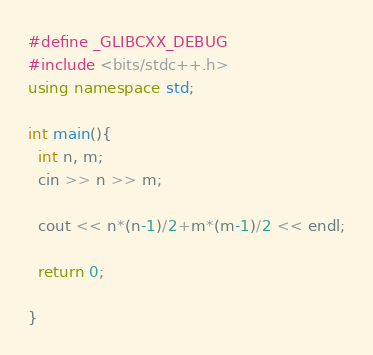Convert code to text. <code><loc_0><loc_0><loc_500><loc_500><_C++_>#define _GLIBCXX_DEBUG
#include <bits/stdc++.h>
using namespace std;

int main(){
  int n, m;
  cin >> n >> m;
  
  cout << n*(n-1)/2+m*(m-1)/2 << endl;
  
  return 0;
  
}</code> 